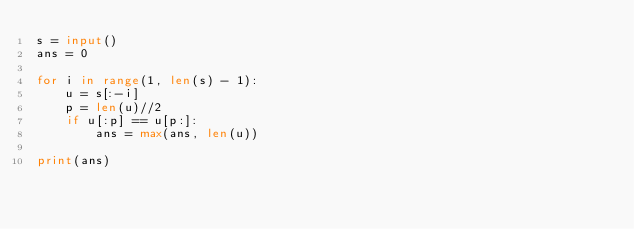<code> <loc_0><loc_0><loc_500><loc_500><_Python_>s = input()
ans = 0

for i in range(1, len(s) - 1):
    u = s[:-i]
    p = len(u)//2
    if u[:p] == u[p:]:
        ans = max(ans, len(u))

print(ans)</code> 